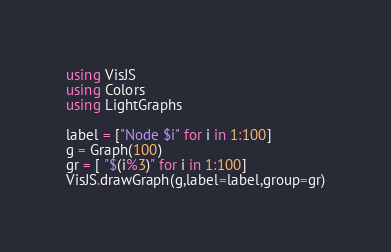<code> <loc_0><loc_0><loc_500><loc_500><_Julia_>using VisJS
using Colors
using LightGraphs

label = ["Node $i" for i in 1:100]
g = Graph(100)
gr = [ "$(i%3)" for i in 1:100]
VisJS.drawGraph(g,label=label,group=gr)
</code> 